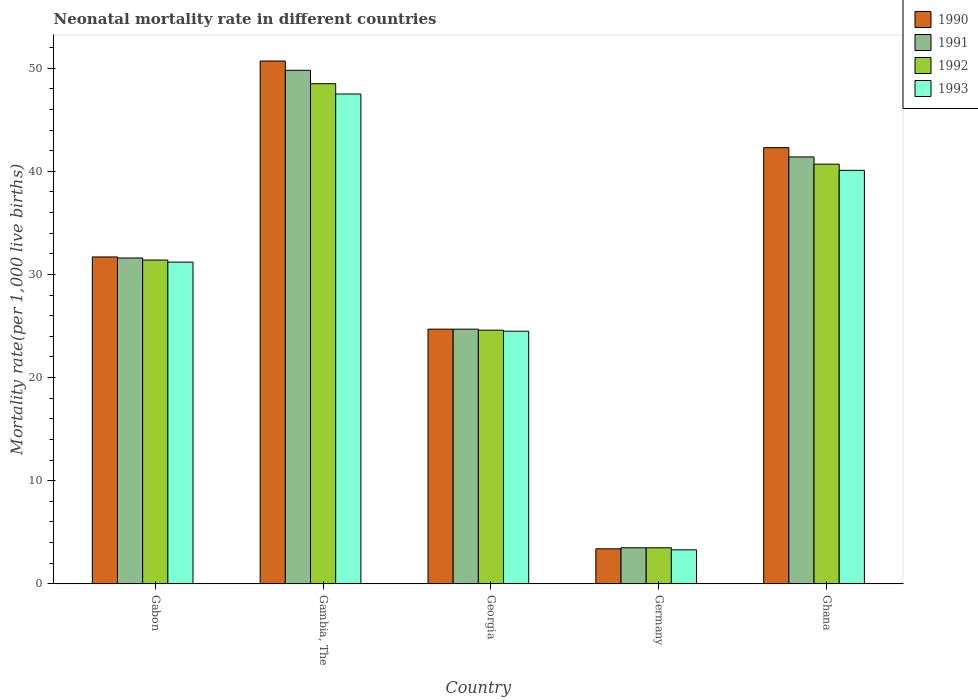How many different coloured bars are there?
Your answer should be compact. 4. Are the number of bars per tick equal to the number of legend labels?
Keep it short and to the point. Yes. Are the number of bars on each tick of the X-axis equal?
Your response must be concise. Yes. How many bars are there on the 2nd tick from the right?
Make the answer very short. 4. What is the label of the 2nd group of bars from the left?
Provide a short and direct response. Gambia, The. What is the neonatal mortality rate in 1991 in Ghana?
Your answer should be compact. 41.4. Across all countries, what is the maximum neonatal mortality rate in 1990?
Ensure brevity in your answer.  50.7. In which country was the neonatal mortality rate in 1992 maximum?
Your answer should be compact. Gambia, The. In which country was the neonatal mortality rate in 1991 minimum?
Offer a very short reply. Germany. What is the total neonatal mortality rate in 1993 in the graph?
Offer a very short reply. 146.6. What is the difference between the neonatal mortality rate in 1990 in Gambia, The and that in Georgia?
Offer a terse response. 26. What is the difference between the neonatal mortality rate in 1990 in Gabon and the neonatal mortality rate in 1991 in Germany?
Give a very brief answer. 28.2. What is the average neonatal mortality rate in 1991 per country?
Your answer should be very brief. 30.2. What is the ratio of the neonatal mortality rate in 1991 in Gabon to that in Germany?
Make the answer very short. 9.03. What is the difference between the highest and the second highest neonatal mortality rate in 1992?
Make the answer very short. 7.8. In how many countries, is the neonatal mortality rate in 1991 greater than the average neonatal mortality rate in 1991 taken over all countries?
Your response must be concise. 3. Is the sum of the neonatal mortality rate in 1991 in Gambia, The and Georgia greater than the maximum neonatal mortality rate in 1992 across all countries?
Provide a succinct answer. Yes. Is it the case that in every country, the sum of the neonatal mortality rate in 1990 and neonatal mortality rate in 1992 is greater than the sum of neonatal mortality rate in 1993 and neonatal mortality rate in 1991?
Provide a succinct answer. No. What does the 3rd bar from the left in Georgia represents?
Give a very brief answer. 1992. Is it the case that in every country, the sum of the neonatal mortality rate in 1990 and neonatal mortality rate in 1992 is greater than the neonatal mortality rate in 1993?
Your answer should be compact. Yes. How many bars are there?
Your answer should be compact. 20. What is the difference between two consecutive major ticks on the Y-axis?
Give a very brief answer. 10. Are the values on the major ticks of Y-axis written in scientific E-notation?
Offer a terse response. No. Does the graph contain any zero values?
Your answer should be compact. No. How many legend labels are there?
Give a very brief answer. 4. What is the title of the graph?
Provide a short and direct response. Neonatal mortality rate in different countries. Does "2001" appear as one of the legend labels in the graph?
Your response must be concise. No. What is the label or title of the X-axis?
Provide a short and direct response. Country. What is the label or title of the Y-axis?
Give a very brief answer. Mortality rate(per 1,0 live births). What is the Mortality rate(per 1,000 live births) of 1990 in Gabon?
Your answer should be very brief. 31.7. What is the Mortality rate(per 1,000 live births) in 1991 in Gabon?
Your answer should be compact. 31.6. What is the Mortality rate(per 1,000 live births) in 1992 in Gabon?
Provide a succinct answer. 31.4. What is the Mortality rate(per 1,000 live births) of 1993 in Gabon?
Offer a terse response. 31.2. What is the Mortality rate(per 1,000 live births) in 1990 in Gambia, The?
Provide a short and direct response. 50.7. What is the Mortality rate(per 1,000 live births) of 1991 in Gambia, The?
Offer a terse response. 49.8. What is the Mortality rate(per 1,000 live births) of 1992 in Gambia, The?
Provide a succinct answer. 48.5. What is the Mortality rate(per 1,000 live births) in 1993 in Gambia, The?
Give a very brief answer. 47.5. What is the Mortality rate(per 1,000 live births) of 1990 in Georgia?
Your response must be concise. 24.7. What is the Mortality rate(per 1,000 live births) of 1991 in Georgia?
Keep it short and to the point. 24.7. What is the Mortality rate(per 1,000 live births) of 1992 in Georgia?
Your response must be concise. 24.6. What is the Mortality rate(per 1,000 live births) of 1990 in Germany?
Your answer should be compact. 3.4. What is the Mortality rate(per 1,000 live births) of 1990 in Ghana?
Offer a terse response. 42.3. What is the Mortality rate(per 1,000 live births) of 1991 in Ghana?
Your response must be concise. 41.4. What is the Mortality rate(per 1,000 live births) in 1992 in Ghana?
Keep it short and to the point. 40.7. What is the Mortality rate(per 1,000 live births) in 1993 in Ghana?
Offer a very short reply. 40.1. Across all countries, what is the maximum Mortality rate(per 1,000 live births) in 1990?
Your response must be concise. 50.7. Across all countries, what is the maximum Mortality rate(per 1,000 live births) in 1991?
Make the answer very short. 49.8. Across all countries, what is the maximum Mortality rate(per 1,000 live births) in 1992?
Provide a succinct answer. 48.5. Across all countries, what is the maximum Mortality rate(per 1,000 live births) in 1993?
Give a very brief answer. 47.5. Across all countries, what is the minimum Mortality rate(per 1,000 live births) in 1990?
Provide a short and direct response. 3.4. Across all countries, what is the minimum Mortality rate(per 1,000 live births) of 1992?
Offer a very short reply. 3.5. What is the total Mortality rate(per 1,000 live births) in 1990 in the graph?
Provide a succinct answer. 152.8. What is the total Mortality rate(per 1,000 live births) in 1991 in the graph?
Keep it short and to the point. 151. What is the total Mortality rate(per 1,000 live births) of 1992 in the graph?
Provide a succinct answer. 148.7. What is the total Mortality rate(per 1,000 live births) in 1993 in the graph?
Your response must be concise. 146.6. What is the difference between the Mortality rate(per 1,000 live births) of 1991 in Gabon and that in Gambia, The?
Ensure brevity in your answer.  -18.2. What is the difference between the Mortality rate(per 1,000 live births) in 1992 in Gabon and that in Gambia, The?
Your answer should be very brief. -17.1. What is the difference between the Mortality rate(per 1,000 live births) of 1993 in Gabon and that in Gambia, The?
Provide a succinct answer. -16.3. What is the difference between the Mortality rate(per 1,000 live births) in 1991 in Gabon and that in Georgia?
Make the answer very short. 6.9. What is the difference between the Mortality rate(per 1,000 live births) in 1992 in Gabon and that in Georgia?
Your answer should be very brief. 6.8. What is the difference between the Mortality rate(per 1,000 live births) in 1993 in Gabon and that in Georgia?
Your answer should be compact. 6.7. What is the difference between the Mortality rate(per 1,000 live births) of 1990 in Gabon and that in Germany?
Keep it short and to the point. 28.3. What is the difference between the Mortality rate(per 1,000 live births) in 1991 in Gabon and that in Germany?
Your answer should be very brief. 28.1. What is the difference between the Mortality rate(per 1,000 live births) in 1992 in Gabon and that in Germany?
Your response must be concise. 27.9. What is the difference between the Mortality rate(per 1,000 live births) of 1993 in Gabon and that in Germany?
Your response must be concise. 27.9. What is the difference between the Mortality rate(per 1,000 live births) of 1990 in Gabon and that in Ghana?
Offer a very short reply. -10.6. What is the difference between the Mortality rate(per 1,000 live births) of 1991 in Gabon and that in Ghana?
Keep it short and to the point. -9.8. What is the difference between the Mortality rate(per 1,000 live births) in 1990 in Gambia, The and that in Georgia?
Ensure brevity in your answer.  26. What is the difference between the Mortality rate(per 1,000 live births) of 1991 in Gambia, The and that in Georgia?
Provide a short and direct response. 25.1. What is the difference between the Mortality rate(per 1,000 live births) of 1992 in Gambia, The and that in Georgia?
Keep it short and to the point. 23.9. What is the difference between the Mortality rate(per 1,000 live births) in 1990 in Gambia, The and that in Germany?
Provide a succinct answer. 47.3. What is the difference between the Mortality rate(per 1,000 live births) of 1991 in Gambia, The and that in Germany?
Provide a short and direct response. 46.3. What is the difference between the Mortality rate(per 1,000 live births) of 1993 in Gambia, The and that in Germany?
Make the answer very short. 44.2. What is the difference between the Mortality rate(per 1,000 live births) in 1992 in Gambia, The and that in Ghana?
Ensure brevity in your answer.  7.8. What is the difference between the Mortality rate(per 1,000 live births) of 1990 in Georgia and that in Germany?
Provide a short and direct response. 21.3. What is the difference between the Mortality rate(per 1,000 live births) in 1991 in Georgia and that in Germany?
Offer a very short reply. 21.2. What is the difference between the Mortality rate(per 1,000 live births) in 1992 in Georgia and that in Germany?
Make the answer very short. 21.1. What is the difference between the Mortality rate(per 1,000 live births) of 1993 in Georgia and that in Germany?
Give a very brief answer. 21.2. What is the difference between the Mortality rate(per 1,000 live births) in 1990 in Georgia and that in Ghana?
Make the answer very short. -17.6. What is the difference between the Mortality rate(per 1,000 live births) in 1991 in Georgia and that in Ghana?
Make the answer very short. -16.7. What is the difference between the Mortality rate(per 1,000 live births) of 1992 in Georgia and that in Ghana?
Keep it short and to the point. -16.1. What is the difference between the Mortality rate(per 1,000 live births) in 1993 in Georgia and that in Ghana?
Provide a short and direct response. -15.6. What is the difference between the Mortality rate(per 1,000 live births) of 1990 in Germany and that in Ghana?
Provide a short and direct response. -38.9. What is the difference between the Mortality rate(per 1,000 live births) in 1991 in Germany and that in Ghana?
Offer a terse response. -37.9. What is the difference between the Mortality rate(per 1,000 live births) of 1992 in Germany and that in Ghana?
Your response must be concise. -37.2. What is the difference between the Mortality rate(per 1,000 live births) in 1993 in Germany and that in Ghana?
Provide a short and direct response. -36.8. What is the difference between the Mortality rate(per 1,000 live births) in 1990 in Gabon and the Mortality rate(per 1,000 live births) in 1991 in Gambia, The?
Your response must be concise. -18.1. What is the difference between the Mortality rate(per 1,000 live births) of 1990 in Gabon and the Mortality rate(per 1,000 live births) of 1992 in Gambia, The?
Provide a succinct answer. -16.8. What is the difference between the Mortality rate(per 1,000 live births) in 1990 in Gabon and the Mortality rate(per 1,000 live births) in 1993 in Gambia, The?
Your answer should be compact. -15.8. What is the difference between the Mortality rate(per 1,000 live births) in 1991 in Gabon and the Mortality rate(per 1,000 live births) in 1992 in Gambia, The?
Your answer should be very brief. -16.9. What is the difference between the Mortality rate(per 1,000 live births) in 1991 in Gabon and the Mortality rate(per 1,000 live births) in 1993 in Gambia, The?
Provide a short and direct response. -15.9. What is the difference between the Mortality rate(per 1,000 live births) in 1992 in Gabon and the Mortality rate(per 1,000 live births) in 1993 in Gambia, The?
Give a very brief answer. -16.1. What is the difference between the Mortality rate(per 1,000 live births) of 1990 in Gabon and the Mortality rate(per 1,000 live births) of 1991 in Georgia?
Ensure brevity in your answer.  7. What is the difference between the Mortality rate(per 1,000 live births) of 1991 in Gabon and the Mortality rate(per 1,000 live births) of 1993 in Georgia?
Give a very brief answer. 7.1. What is the difference between the Mortality rate(per 1,000 live births) of 1992 in Gabon and the Mortality rate(per 1,000 live births) of 1993 in Georgia?
Provide a short and direct response. 6.9. What is the difference between the Mortality rate(per 1,000 live births) of 1990 in Gabon and the Mortality rate(per 1,000 live births) of 1991 in Germany?
Your answer should be compact. 28.2. What is the difference between the Mortality rate(per 1,000 live births) in 1990 in Gabon and the Mortality rate(per 1,000 live births) in 1992 in Germany?
Your answer should be very brief. 28.2. What is the difference between the Mortality rate(per 1,000 live births) in 1990 in Gabon and the Mortality rate(per 1,000 live births) in 1993 in Germany?
Ensure brevity in your answer.  28.4. What is the difference between the Mortality rate(per 1,000 live births) in 1991 in Gabon and the Mortality rate(per 1,000 live births) in 1992 in Germany?
Keep it short and to the point. 28.1. What is the difference between the Mortality rate(per 1,000 live births) of 1991 in Gabon and the Mortality rate(per 1,000 live births) of 1993 in Germany?
Ensure brevity in your answer.  28.3. What is the difference between the Mortality rate(per 1,000 live births) of 1992 in Gabon and the Mortality rate(per 1,000 live births) of 1993 in Germany?
Keep it short and to the point. 28.1. What is the difference between the Mortality rate(per 1,000 live births) in 1990 in Gabon and the Mortality rate(per 1,000 live births) in 1991 in Ghana?
Ensure brevity in your answer.  -9.7. What is the difference between the Mortality rate(per 1,000 live births) of 1990 in Gabon and the Mortality rate(per 1,000 live births) of 1993 in Ghana?
Offer a very short reply. -8.4. What is the difference between the Mortality rate(per 1,000 live births) of 1990 in Gambia, The and the Mortality rate(per 1,000 live births) of 1991 in Georgia?
Your answer should be compact. 26. What is the difference between the Mortality rate(per 1,000 live births) in 1990 in Gambia, The and the Mortality rate(per 1,000 live births) in 1992 in Georgia?
Provide a short and direct response. 26.1. What is the difference between the Mortality rate(per 1,000 live births) of 1990 in Gambia, The and the Mortality rate(per 1,000 live births) of 1993 in Georgia?
Your response must be concise. 26.2. What is the difference between the Mortality rate(per 1,000 live births) of 1991 in Gambia, The and the Mortality rate(per 1,000 live births) of 1992 in Georgia?
Give a very brief answer. 25.2. What is the difference between the Mortality rate(per 1,000 live births) of 1991 in Gambia, The and the Mortality rate(per 1,000 live births) of 1993 in Georgia?
Provide a succinct answer. 25.3. What is the difference between the Mortality rate(per 1,000 live births) of 1992 in Gambia, The and the Mortality rate(per 1,000 live births) of 1993 in Georgia?
Make the answer very short. 24. What is the difference between the Mortality rate(per 1,000 live births) in 1990 in Gambia, The and the Mortality rate(per 1,000 live births) in 1991 in Germany?
Provide a short and direct response. 47.2. What is the difference between the Mortality rate(per 1,000 live births) of 1990 in Gambia, The and the Mortality rate(per 1,000 live births) of 1992 in Germany?
Provide a short and direct response. 47.2. What is the difference between the Mortality rate(per 1,000 live births) of 1990 in Gambia, The and the Mortality rate(per 1,000 live births) of 1993 in Germany?
Your answer should be compact. 47.4. What is the difference between the Mortality rate(per 1,000 live births) in 1991 in Gambia, The and the Mortality rate(per 1,000 live births) in 1992 in Germany?
Your response must be concise. 46.3. What is the difference between the Mortality rate(per 1,000 live births) in 1991 in Gambia, The and the Mortality rate(per 1,000 live births) in 1993 in Germany?
Keep it short and to the point. 46.5. What is the difference between the Mortality rate(per 1,000 live births) of 1992 in Gambia, The and the Mortality rate(per 1,000 live births) of 1993 in Germany?
Provide a short and direct response. 45.2. What is the difference between the Mortality rate(per 1,000 live births) in 1990 in Gambia, The and the Mortality rate(per 1,000 live births) in 1991 in Ghana?
Your answer should be very brief. 9.3. What is the difference between the Mortality rate(per 1,000 live births) in 1990 in Gambia, The and the Mortality rate(per 1,000 live births) in 1992 in Ghana?
Your answer should be compact. 10. What is the difference between the Mortality rate(per 1,000 live births) of 1991 in Gambia, The and the Mortality rate(per 1,000 live births) of 1993 in Ghana?
Make the answer very short. 9.7. What is the difference between the Mortality rate(per 1,000 live births) in 1992 in Gambia, The and the Mortality rate(per 1,000 live births) in 1993 in Ghana?
Make the answer very short. 8.4. What is the difference between the Mortality rate(per 1,000 live births) in 1990 in Georgia and the Mortality rate(per 1,000 live births) in 1991 in Germany?
Offer a terse response. 21.2. What is the difference between the Mortality rate(per 1,000 live births) of 1990 in Georgia and the Mortality rate(per 1,000 live births) of 1992 in Germany?
Offer a very short reply. 21.2. What is the difference between the Mortality rate(per 1,000 live births) in 1990 in Georgia and the Mortality rate(per 1,000 live births) in 1993 in Germany?
Ensure brevity in your answer.  21.4. What is the difference between the Mortality rate(per 1,000 live births) in 1991 in Georgia and the Mortality rate(per 1,000 live births) in 1992 in Germany?
Give a very brief answer. 21.2. What is the difference between the Mortality rate(per 1,000 live births) in 1991 in Georgia and the Mortality rate(per 1,000 live births) in 1993 in Germany?
Provide a succinct answer. 21.4. What is the difference between the Mortality rate(per 1,000 live births) of 1992 in Georgia and the Mortality rate(per 1,000 live births) of 1993 in Germany?
Provide a succinct answer. 21.3. What is the difference between the Mortality rate(per 1,000 live births) in 1990 in Georgia and the Mortality rate(per 1,000 live births) in 1991 in Ghana?
Your response must be concise. -16.7. What is the difference between the Mortality rate(per 1,000 live births) in 1990 in Georgia and the Mortality rate(per 1,000 live births) in 1992 in Ghana?
Your answer should be compact. -16. What is the difference between the Mortality rate(per 1,000 live births) in 1990 in Georgia and the Mortality rate(per 1,000 live births) in 1993 in Ghana?
Ensure brevity in your answer.  -15.4. What is the difference between the Mortality rate(per 1,000 live births) in 1991 in Georgia and the Mortality rate(per 1,000 live births) in 1992 in Ghana?
Your response must be concise. -16. What is the difference between the Mortality rate(per 1,000 live births) in 1991 in Georgia and the Mortality rate(per 1,000 live births) in 1993 in Ghana?
Your answer should be very brief. -15.4. What is the difference between the Mortality rate(per 1,000 live births) of 1992 in Georgia and the Mortality rate(per 1,000 live births) of 1993 in Ghana?
Your answer should be very brief. -15.5. What is the difference between the Mortality rate(per 1,000 live births) of 1990 in Germany and the Mortality rate(per 1,000 live births) of 1991 in Ghana?
Your answer should be very brief. -38. What is the difference between the Mortality rate(per 1,000 live births) in 1990 in Germany and the Mortality rate(per 1,000 live births) in 1992 in Ghana?
Give a very brief answer. -37.3. What is the difference between the Mortality rate(per 1,000 live births) of 1990 in Germany and the Mortality rate(per 1,000 live births) of 1993 in Ghana?
Your answer should be compact. -36.7. What is the difference between the Mortality rate(per 1,000 live births) of 1991 in Germany and the Mortality rate(per 1,000 live births) of 1992 in Ghana?
Provide a short and direct response. -37.2. What is the difference between the Mortality rate(per 1,000 live births) of 1991 in Germany and the Mortality rate(per 1,000 live births) of 1993 in Ghana?
Offer a terse response. -36.6. What is the difference between the Mortality rate(per 1,000 live births) of 1992 in Germany and the Mortality rate(per 1,000 live births) of 1993 in Ghana?
Your response must be concise. -36.6. What is the average Mortality rate(per 1,000 live births) of 1990 per country?
Your answer should be very brief. 30.56. What is the average Mortality rate(per 1,000 live births) of 1991 per country?
Give a very brief answer. 30.2. What is the average Mortality rate(per 1,000 live births) of 1992 per country?
Give a very brief answer. 29.74. What is the average Mortality rate(per 1,000 live births) in 1993 per country?
Offer a terse response. 29.32. What is the difference between the Mortality rate(per 1,000 live births) of 1990 and Mortality rate(per 1,000 live births) of 1992 in Gabon?
Offer a terse response. 0.3. What is the difference between the Mortality rate(per 1,000 live births) of 1992 and Mortality rate(per 1,000 live births) of 1993 in Gabon?
Your answer should be compact. 0.2. What is the difference between the Mortality rate(per 1,000 live births) in 1990 and Mortality rate(per 1,000 live births) in 1992 in Gambia, The?
Your answer should be very brief. 2.2. What is the difference between the Mortality rate(per 1,000 live births) of 1991 and Mortality rate(per 1,000 live births) of 1992 in Gambia, The?
Keep it short and to the point. 1.3. What is the difference between the Mortality rate(per 1,000 live births) of 1992 and Mortality rate(per 1,000 live births) of 1993 in Gambia, The?
Ensure brevity in your answer.  1. What is the difference between the Mortality rate(per 1,000 live births) of 1990 and Mortality rate(per 1,000 live births) of 1991 in Georgia?
Keep it short and to the point. 0. What is the difference between the Mortality rate(per 1,000 live births) of 1990 and Mortality rate(per 1,000 live births) of 1992 in Georgia?
Your answer should be very brief. 0.1. What is the difference between the Mortality rate(per 1,000 live births) in 1991 and Mortality rate(per 1,000 live births) in 1992 in Georgia?
Provide a short and direct response. 0.1. What is the difference between the Mortality rate(per 1,000 live births) in 1990 and Mortality rate(per 1,000 live births) in 1991 in Germany?
Offer a terse response. -0.1. What is the difference between the Mortality rate(per 1,000 live births) in 1990 and Mortality rate(per 1,000 live births) in 1993 in Germany?
Provide a short and direct response. 0.1. What is the difference between the Mortality rate(per 1,000 live births) in 1992 and Mortality rate(per 1,000 live births) in 1993 in Germany?
Make the answer very short. 0.2. What is the difference between the Mortality rate(per 1,000 live births) in 1990 and Mortality rate(per 1,000 live births) in 1991 in Ghana?
Provide a short and direct response. 0.9. What is the difference between the Mortality rate(per 1,000 live births) in 1990 and Mortality rate(per 1,000 live births) in 1993 in Ghana?
Offer a very short reply. 2.2. What is the difference between the Mortality rate(per 1,000 live births) in 1991 and Mortality rate(per 1,000 live births) in 1992 in Ghana?
Your answer should be compact. 0.7. What is the difference between the Mortality rate(per 1,000 live births) of 1991 and Mortality rate(per 1,000 live births) of 1993 in Ghana?
Provide a short and direct response. 1.3. What is the ratio of the Mortality rate(per 1,000 live births) in 1990 in Gabon to that in Gambia, The?
Provide a succinct answer. 0.63. What is the ratio of the Mortality rate(per 1,000 live births) of 1991 in Gabon to that in Gambia, The?
Make the answer very short. 0.63. What is the ratio of the Mortality rate(per 1,000 live births) of 1992 in Gabon to that in Gambia, The?
Your response must be concise. 0.65. What is the ratio of the Mortality rate(per 1,000 live births) of 1993 in Gabon to that in Gambia, The?
Your answer should be very brief. 0.66. What is the ratio of the Mortality rate(per 1,000 live births) in 1990 in Gabon to that in Georgia?
Provide a short and direct response. 1.28. What is the ratio of the Mortality rate(per 1,000 live births) of 1991 in Gabon to that in Georgia?
Offer a terse response. 1.28. What is the ratio of the Mortality rate(per 1,000 live births) of 1992 in Gabon to that in Georgia?
Your answer should be compact. 1.28. What is the ratio of the Mortality rate(per 1,000 live births) in 1993 in Gabon to that in Georgia?
Provide a succinct answer. 1.27. What is the ratio of the Mortality rate(per 1,000 live births) in 1990 in Gabon to that in Germany?
Provide a succinct answer. 9.32. What is the ratio of the Mortality rate(per 1,000 live births) of 1991 in Gabon to that in Germany?
Make the answer very short. 9.03. What is the ratio of the Mortality rate(per 1,000 live births) in 1992 in Gabon to that in Germany?
Offer a terse response. 8.97. What is the ratio of the Mortality rate(per 1,000 live births) of 1993 in Gabon to that in Germany?
Your answer should be very brief. 9.45. What is the ratio of the Mortality rate(per 1,000 live births) of 1990 in Gabon to that in Ghana?
Offer a very short reply. 0.75. What is the ratio of the Mortality rate(per 1,000 live births) in 1991 in Gabon to that in Ghana?
Provide a short and direct response. 0.76. What is the ratio of the Mortality rate(per 1,000 live births) in 1992 in Gabon to that in Ghana?
Your answer should be compact. 0.77. What is the ratio of the Mortality rate(per 1,000 live births) of 1993 in Gabon to that in Ghana?
Offer a terse response. 0.78. What is the ratio of the Mortality rate(per 1,000 live births) in 1990 in Gambia, The to that in Georgia?
Give a very brief answer. 2.05. What is the ratio of the Mortality rate(per 1,000 live births) of 1991 in Gambia, The to that in Georgia?
Your answer should be very brief. 2.02. What is the ratio of the Mortality rate(per 1,000 live births) in 1992 in Gambia, The to that in Georgia?
Ensure brevity in your answer.  1.97. What is the ratio of the Mortality rate(per 1,000 live births) of 1993 in Gambia, The to that in Georgia?
Give a very brief answer. 1.94. What is the ratio of the Mortality rate(per 1,000 live births) in 1990 in Gambia, The to that in Germany?
Your response must be concise. 14.91. What is the ratio of the Mortality rate(per 1,000 live births) in 1991 in Gambia, The to that in Germany?
Your response must be concise. 14.23. What is the ratio of the Mortality rate(per 1,000 live births) of 1992 in Gambia, The to that in Germany?
Give a very brief answer. 13.86. What is the ratio of the Mortality rate(per 1,000 live births) in 1993 in Gambia, The to that in Germany?
Your answer should be compact. 14.39. What is the ratio of the Mortality rate(per 1,000 live births) of 1990 in Gambia, The to that in Ghana?
Offer a terse response. 1.2. What is the ratio of the Mortality rate(per 1,000 live births) in 1991 in Gambia, The to that in Ghana?
Your answer should be compact. 1.2. What is the ratio of the Mortality rate(per 1,000 live births) in 1992 in Gambia, The to that in Ghana?
Offer a very short reply. 1.19. What is the ratio of the Mortality rate(per 1,000 live births) of 1993 in Gambia, The to that in Ghana?
Provide a succinct answer. 1.18. What is the ratio of the Mortality rate(per 1,000 live births) of 1990 in Georgia to that in Germany?
Offer a terse response. 7.26. What is the ratio of the Mortality rate(per 1,000 live births) in 1991 in Georgia to that in Germany?
Offer a very short reply. 7.06. What is the ratio of the Mortality rate(per 1,000 live births) of 1992 in Georgia to that in Germany?
Provide a succinct answer. 7.03. What is the ratio of the Mortality rate(per 1,000 live births) in 1993 in Georgia to that in Germany?
Make the answer very short. 7.42. What is the ratio of the Mortality rate(per 1,000 live births) in 1990 in Georgia to that in Ghana?
Make the answer very short. 0.58. What is the ratio of the Mortality rate(per 1,000 live births) in 1991 in Georgia to that in Ghana?
Make the answer very short. 0.6. What is the ratio of the Mortality rate(per 1,000 live births) of 1992 in Georgia to that in Ghana?
Make the answer very short. 0.6. What is the ratio of the Mortality rate(per 1,000 live births) in 1993 in Georgia to that in Ghana?
Offer a very short reply. 0.61. What is the ratio of the Mortality rate(per 1,000 live births) in 1990 in Germany to that in Ghana?
Your answer should be compact. 0.08. What is the ratio of the Mortality rate(per 1,000 live births) in 1991 in Germany to that in Ghana?
Ensure brevity in your answer.  0.08. What is the ratio of the Mortality rate(per 1,000 live births) of 1992 in Germany to that in Ghana?
Your answer should be very brief. 0.09. What is the ratio of the Mortality rate(per 1,000 live births) in 1993 in Germany to that in Ghana?
Offer a very short reply. 0.08. What is the difference between the highest and the second highest Mortality rate(per 1,000 live births) of 1993?
Your answer should be compact. 7.4. What is the difference between the highest and the lowest Mortality rate(per 1,000 live births) of 1990?
Your answer should be compact. 47.3. What is the difference between the highest and the lowest Mortality rate(per 1,000 live births) in 1991?
Offer a very short reply. 46.3. What is the difference between the highest and the lowest Mortality rate(per 1,000 live births) in 1992?
Your answer should be very brief. 45. What is the difference between the highest and the lowest Mortality rate(per 1,000 live births) in 1993?
Your response must be concise. 44.2. 